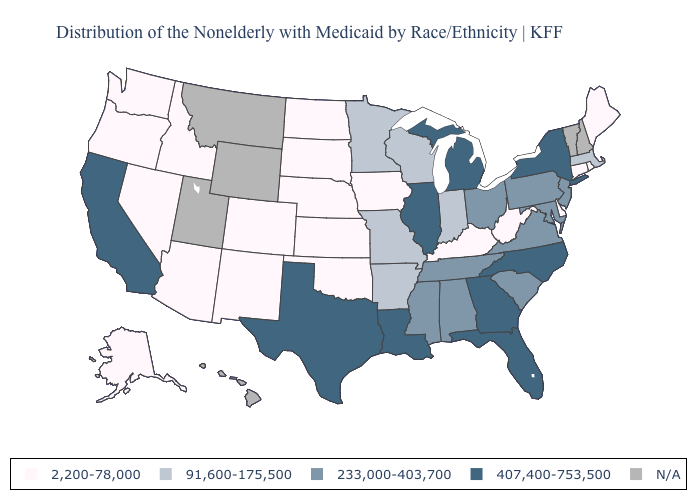Name the states that have a value in the range 233,000-403,700?
Keep it brief. Alabama, Maryland, Mississippi, New Jersey, Ohio, Pennsylvania, South Carolina, Tennessee, Virginia. Name the states that have a value in the range 2,200-78,000?
Write a very short answer. Alaska, Arizona, Colorado, Connecticut, Delaware, Idaho, Iowa, Kansas, Kentucky, Maine, Nebraska, Nevada, New Mexico, North Dakota, Oklahoma, Oregon, Rhode Island, South Dakota, Washington, West Virginia. What is the highest value in states that border Connecticut?
Short answer required. 407,400-753,500. Does the map have missing data?
Keep it brief. Yes. Name the states that have a value in the range 2,200-78,000?
Quick response, please. Alaska, Arizona, Colorado, Connecticut, Delaware, Idaho, Iowa, Kansas, Kentucky, Maine, Nebraska, Nevada, New Mexico, North Dakota, Oklahoma, Oregon, Rhode Island, South Dakota, Washington, West Virginia. What is the highest value in the USA?
Give a very brief answer. 407,400-753,500. What is the lowest value in the South?
Concise answer only. 2,200-78,000. Which states have the highest value in the USA?
Answer briefly. California, Florida, Georgia, Illinois, Louisiana, Michigan, New York, North Carolina, Texas. What is the value of Massachusetts?
Write a very short answer. 91,600-175,500. Among the states that border Nevada , which have the lowest value?
Concise answer only. Arizona, Idaho, Oregon. Among the states that border Pennsylvania , does New York have the highest value?
Be succinct. Yes. Does New Jersey have the highest value in the USA?
Write a very short answer. No. Does Texas have the highest value in the USA?
Be succinct. Yes. Name the states that have a value in the range 2,200-78,000?
Quick response, please. Alaska, Arizona, Colorado, Connecticut, Delaware, Idaho, Iowa, Kansas, Kentucky, Maine, Nebraska, Nevada, New Mexico, North Dakota, Oklahoma, Oregon, Rhode Island, South Dakota, Washington, West Virginia. 